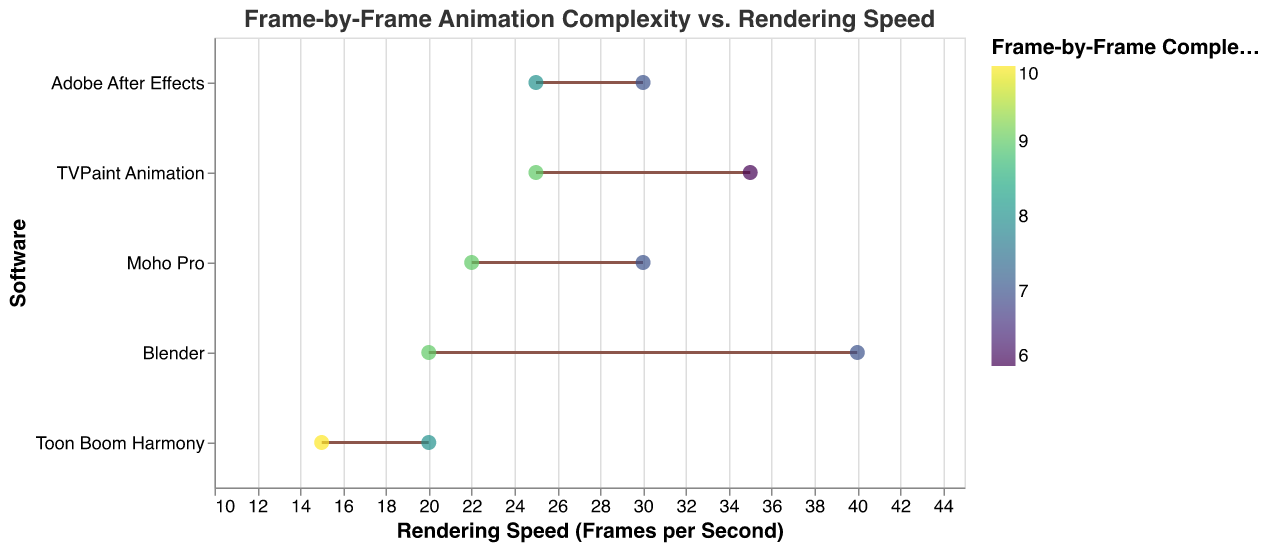What is the title of the plot? The title can be seen at the top of the plot and it reads "Frame-by-Frame Animation Complexity vs. Rendering Speed".
Answer: Frame-by-Frame Animation Complexity vs. Rendering Speed How many software tools are included in the plot? By counting the number of distinct software names on the y-axis of the plot, we find that there are five software tools: Adobe After Effects, Blender, Toon Boom Harmony, TVPaint Animation, and Moho Pro.
Answer: Five Which software has the highest rendering speed when the frame-by-frame complexity is 7? By looking at the points corresponding to a frame-by-frame complexity of 7, Blender has the highest rendering speed of 40 frames per second.
Answer: Blender What color indicates the highest frame-by-frame complexity, and which software reaches this complexity? The color scale on the plot indicates that the highest frame-by-frame complexity (10) is associated with a darker color. This is observed for Toon Boom Harmony.
Answer: Toon Boom Harmony Compare the rendering speed of Moho Pro at frame-by-frame complexities of 7 and 9. Which is faster and by how much? Moho Pro has rendering speeds of 30 frames per second at complexity 7 and 22 frames per second at complexity 9. The difference in speed is 30 - 22 = 8 frames per second.
Answer: 30 fps at complexity 7 is faster by 8 fps What is the average rendering speed of Adobe After Effects across the given frame-by-frame complexities? Adobe After Effects has rendering speeds of 30 and 25 frames per second. The average rendering speed is (30 + 25) / 2 = 27.5 frames per second.
Answer: 27.5 frames per second Is there any software that has the same rendering speed for different frame-by-frame complexities? If so, which one? There is no software that has the same rendering speed for different frame-by-frame complexities, as each point on the plot for a given software shows a distinct rendering speed.
Answer: None Which software maintains a rendering speed above 20 frames per second across all given complexities? Moho Pro, Adobe After Effects, and TVPaint Animation all have rendering speeds above 20 frames per second across all given complexities.
Answer: Moho Pro, Adobe After Effects, TVPaint Animation What is the average frame-by-frame complexity for Blender, and does its rendering speed increase or decrease with complexity? Blender has frame-by-frame complexities of 9 and 7. The average complexity is (9 + 7) / 2 = 8. A complexity of 7 corresponds to a rendering speed of 40 frames per second, and a complexity of 9 corresponds to 20 frames per second. This shows a decrease in rendering speed with increasing complexity.
Answer: 8; Decreases Which software shows the largest range in rendering speeds based on its frame-by-frame complexities? By comparing the range of rendering speeds for each software, Blender stands out with speeds of 40 fps and 20 fps, giving a range of 40 - 20 = 20 fps, which is the largest range.
Answer: Blender 